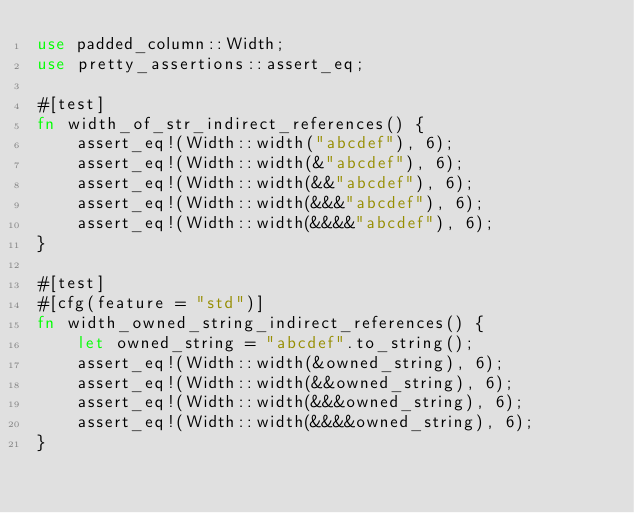Convert code to text. <code><loc_0><loc_0><loc_500><loc_500><_Rust_>use padded_column::Width;
use pretty_assertions::assert_eq;

#[test]
fn width_of_str_indirect_references() {
    assert_eq!(Width::width("abcdef"), 6);
    assert_eq!(Width::width(&"abcdef"), 6);
    assert_eq!(Width::width(&&"abcdef"), 6);
    assert_eq!(Width::width(&&&"abcdef"), 6);
    assert_eq!(Width::width(&&&&"abcdef"), 6);
}

#[test]
#[cfg(feature = "std")]
fn width_owned_string_indirect_references() {
    let owned_string = "abcdef".to_string();
    assert_eq!(Width::width(&owned_string), 6);
    assert_eq!(Width::width(&&owned_string), 6);
    assert_eq!(Width::width(&&&owned_string), 6);
    assert_eq!(Width::width(&&&&owned_string), 6);
}
</code> 